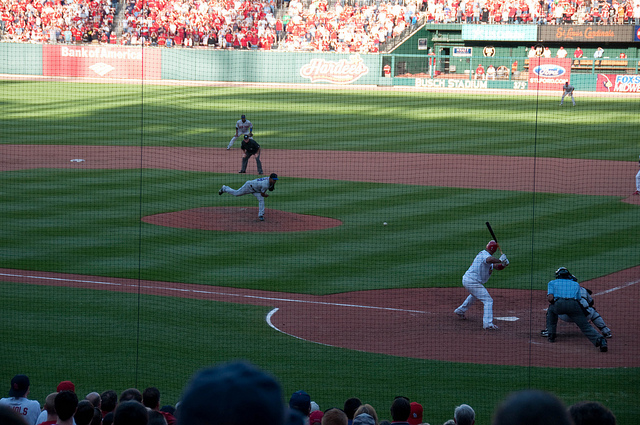Extract all visible text content from this image. Bank STADIUM 